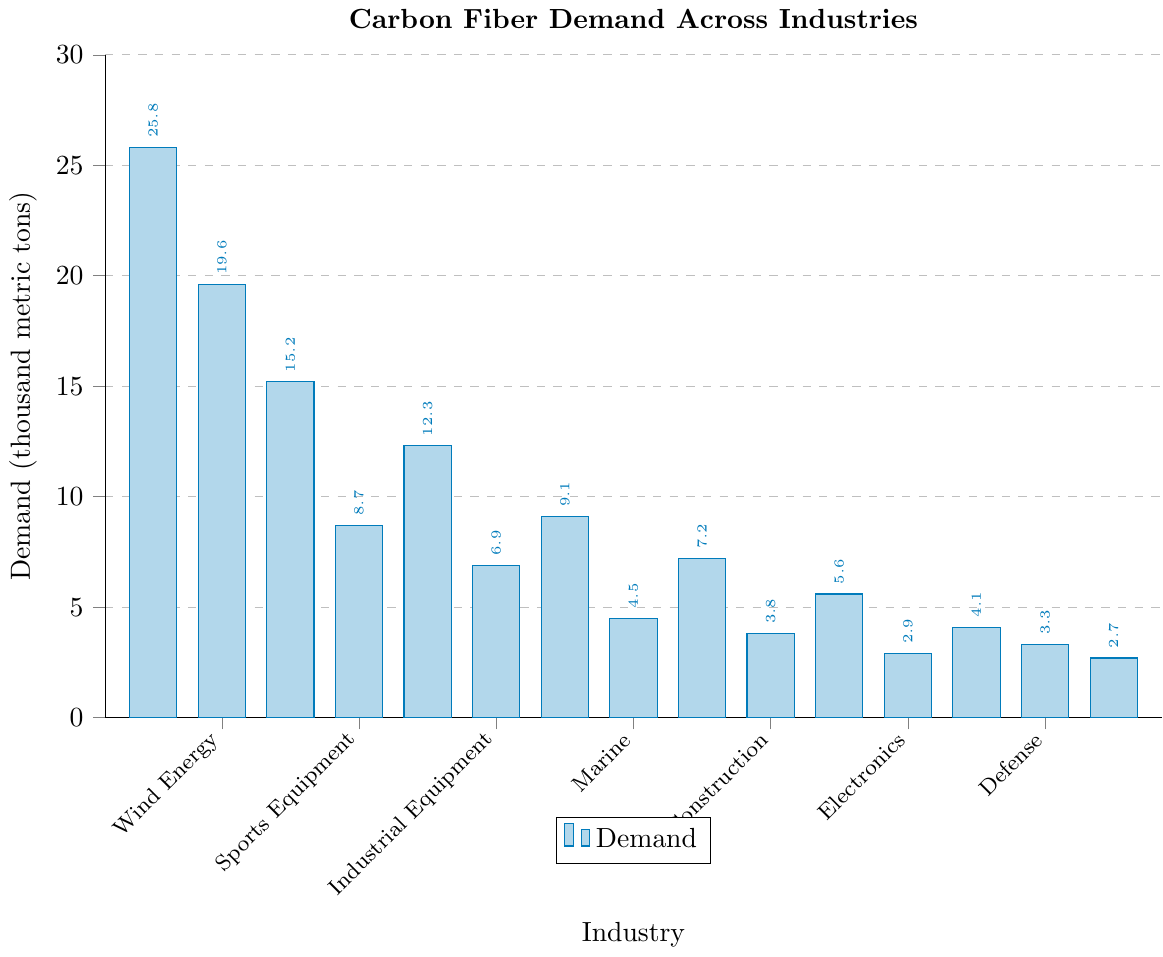Which industry shows the highest demand for carbon fiber? The bar representing Aerospace is the tallest in the chart, indicating the highest demand.
Answer: Aerospace What is the total demand for carbon fiber in the Automotive and Wind Energy industries combined? The demand for Automotive is 19.6 thousand metric tons, and for Wind Energy, it is 15.2 thousand metric tons. Adding these values gives 19.6 + 15.2 = 34.8 thousand metric tons.
Answer: 34.8 How does the demand for carbon fiber in the Sports Equipment industry compare with the Marine industry? The demand for Sports Equipment is 8.7 thousand metric tons, while for Marine, it is 6.9 thousand metric tons. 8.7 is greater than 6.9.
Answer: Sports Equipment Which industry has a lower demand for carbon fiber, Construction or Electronics? The demand for Construction is 9.1 thousand metric tons, and for Electronics, it is 4.5 thousand metric tons. 4.5 is less than 9.1.
Answer: Electronics Arrange the following industries in decreasing order of carbon fiber demand: Marine, Defense, and Consumer Goods. The demands are Marine 6.9 thousand metric tons, Defense 7.2 thousand metric tons, and Consumer Goods 5.6 thousand metric tons. Ordering them from highest to lowest gives Defense > Marine > Consumer Goods.
Answer: Defense, Marine, Consumer Goods What is the difference in demand between Industrial Equipment and Rail industries? The demand for Industrial Equipment is 12.3 thousand metric tons, and for Rail, it is 3.3 thousand metric tons. The difference is 12.3 - 3.3 = 9.0 thousand metric tons.
Answer: 9.0 Which two industries have the closest demand for carbon fiber? Comparing the demands, Medical with 2.9 thousand metric tons and Oil and Gas with 2.7 thousand metric tons are closest, having a difference of 0.2 thousand metric tons.
Answer: Medical and Oil and Gas What percentage of the total demand does the Aerospace industry represent? First, sum all demands: 25.8 + 19.6 + 15.2 + 8.7 + 12.3 + 6.9 + 9.1 + 4.5 + 7.2 + 3.8 + 5.6 + 2.9 + 4.1 + 3.3 + 2.7 = 131.7 thousand metric tons. The demand for Aerospace is 25.8. The percentage is (25.8 / 131.7) * 100 ≈ 19.6%.
Answer: 19.6 Which industry has a demand closest to the average demand across all industries? First, find the average demand: (131.7 / 15) ≈ 8.78 thousand metric tons. The demand for Sports Equipment is 8.7 thousand metric tons, which is closest to 8.78.
Answer: Sports Equipment 